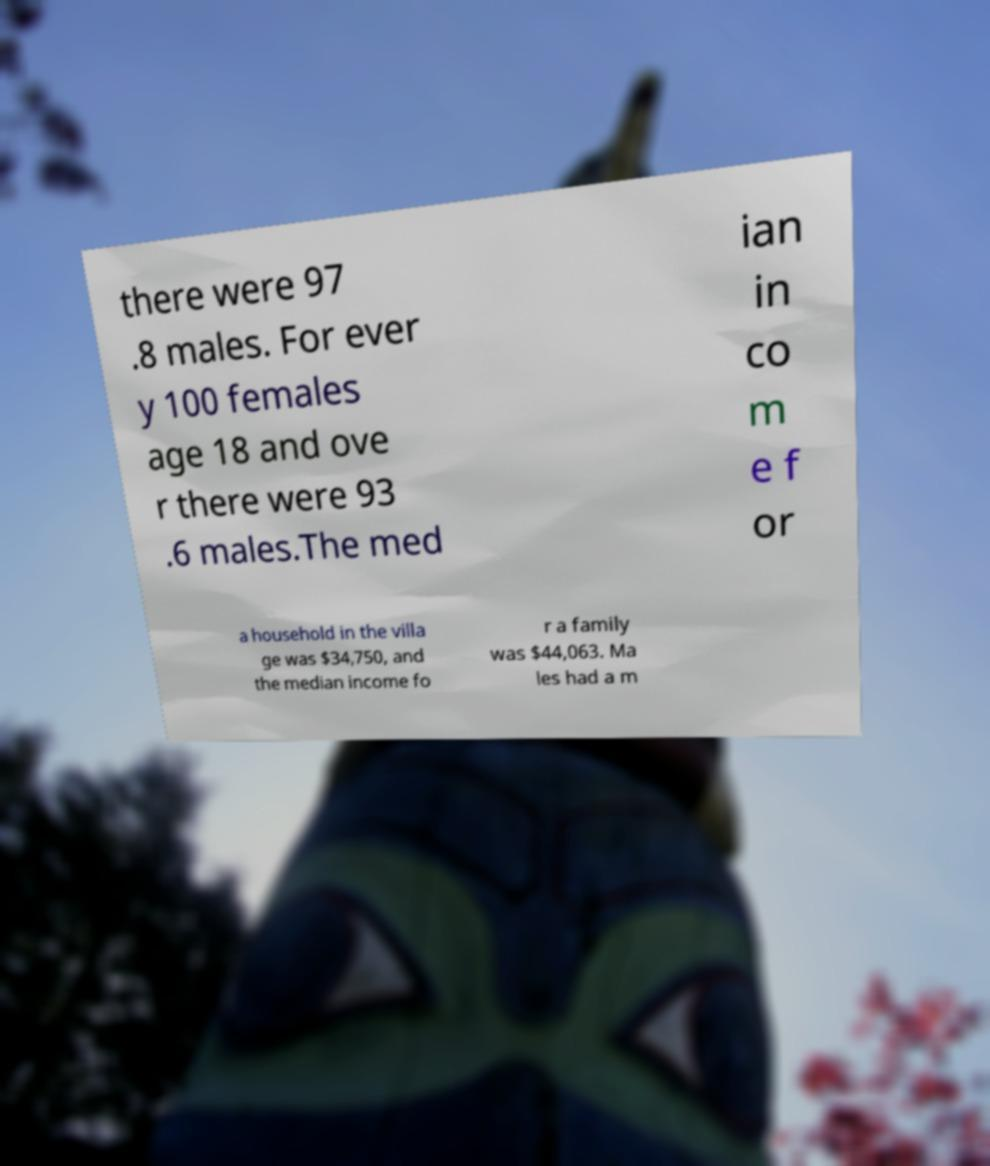Please read and relay the text visible in this image. What does it say? there were 97 .8 males. For ever y 100 females age 18 and ove r there were 93 .6 males.The med ian in co m e f or a household in the villa ge was $34,750, and the median income fo r a family was $44,063. Ma les had a m 